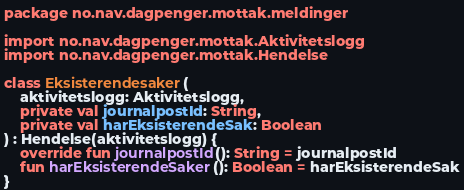<code> <loc_0><loc_0><loc_500><loc_500><_Kotlin_>package no.nav.dagpenger.mottak.meldinger

import no.nav.dagpenger.mottak.Aktivitetslogg
import no.nav.dagpenger.mottak.Hendelse

class Eksisterendesaker(
    aktivitetslogg: Aktivitetslogg,
    private val journalpostId: String,
    private val harEksisterendeSak: Boolean
) : Hendelse(aktivitetslogg) {
    override fun journalpostId(): String = journalpostId
    fun harEksisterendeSaker(): Boolean = harEksisterendeSak
}
</code> 